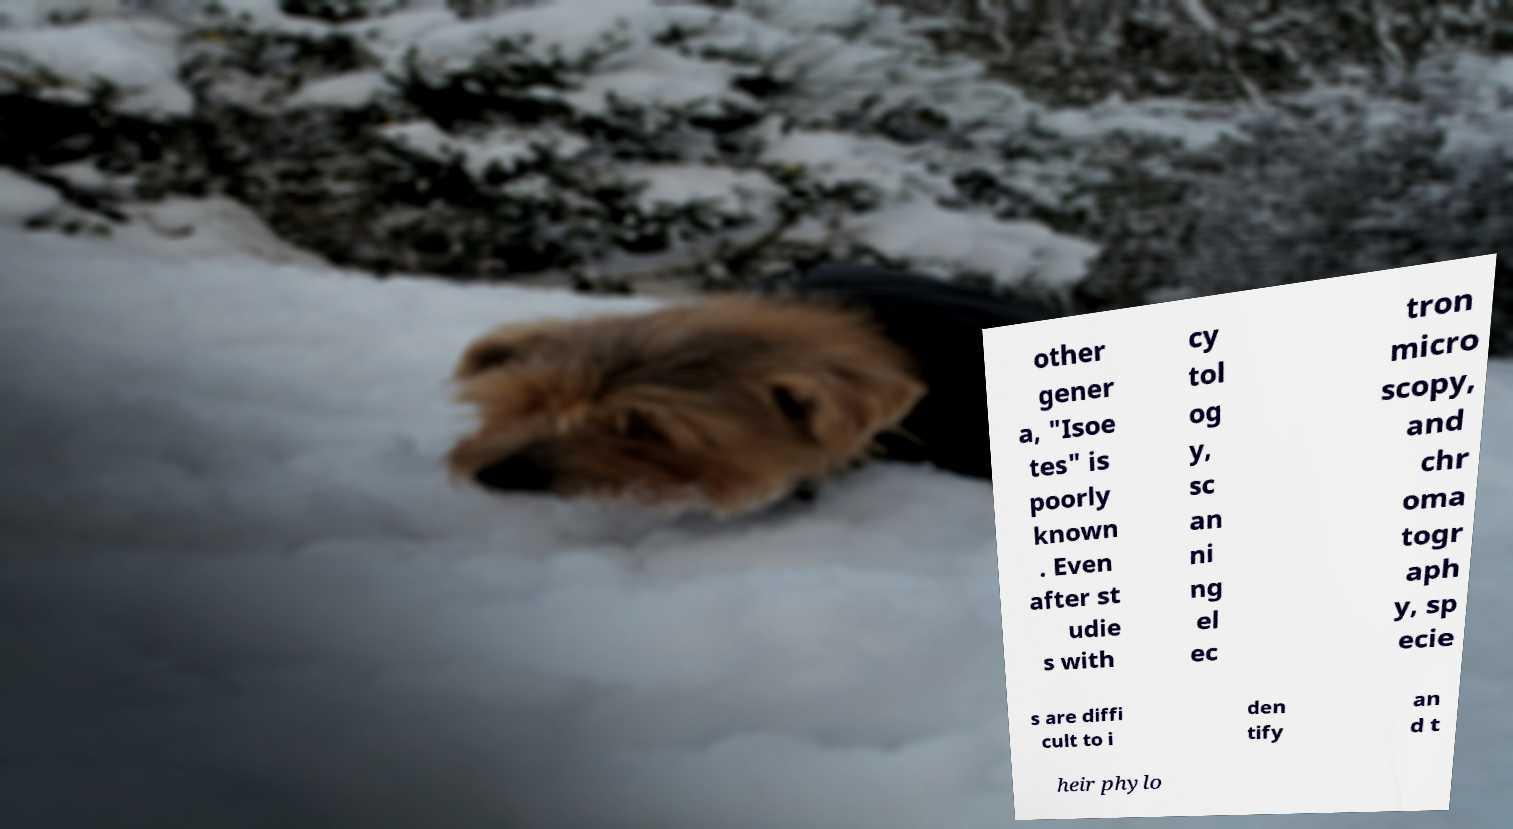Could you extract and type out the text from this image? other gener a, "Isoe tes" is poorly known . Even after st udie s with cy tol og y, sc an ni ng el ec tron micro scopy, and chr oma togr aph y, sp ecie s are diffi cult to i den tify an d t heir phylo 